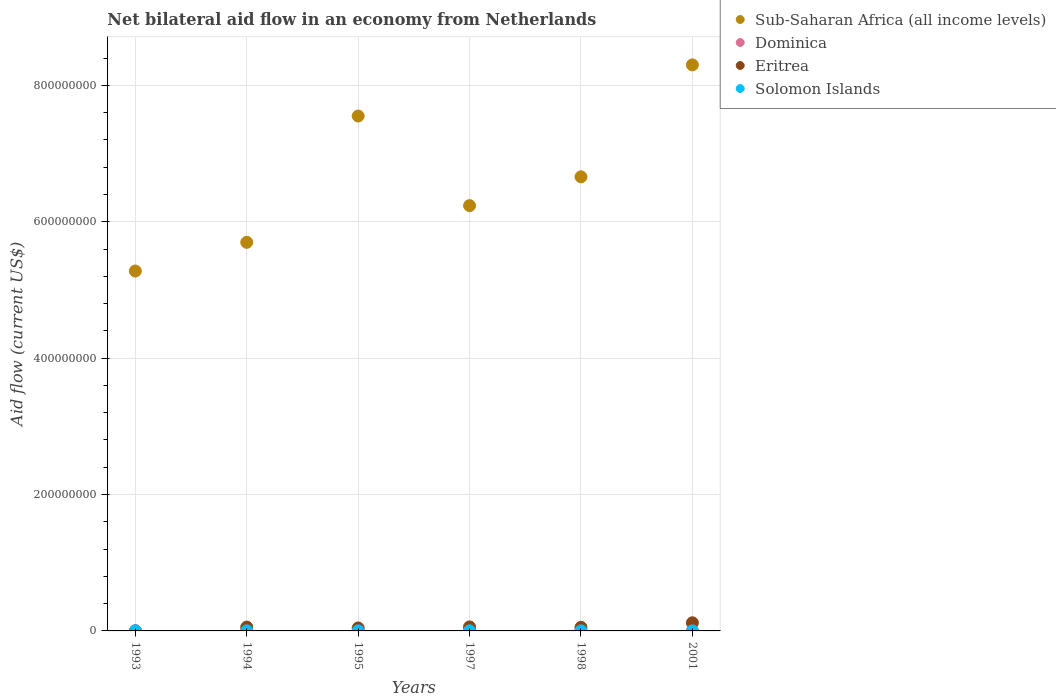How many different coloured dotlines are there?
Keep it short and to the point. 4. What is the net bilateral aid flow in Dominica in 1998?
Provide a short and direct response. 2.10e+05. Across all years, what is the minimum net bilateral aid flow in Sub-Saharan Africa (all income levels)?
Your answer should be compact. 5.28e+08. In which year was the net bilateral aid flow in Sub-Saharan Africa (all income levels) minimum?
Ensure brevity in your answer.  1993. What is the total net bilateral aid flow in Eritrea in the graph?
Give a very brief answer. 3.31e+07. What is the difference between the net bilateral aid flow in Eritrea in 1994 and that in 1998?
Your response must be concise. 2.90e+05. What is the difference between the net bilateral aid flow in Eritrea in 1993 and the net bilateral aid flow in Sub-Saharan Africa (all income levels) in 1995?
Give a very brief answer. -7.55e+08. What is the average net bilateral aid flow in Sub-Saharan Africa (all income levels) per year?
Provide a succinct answer. 6.62e+08. In the year 1994, what is the difference between the net bilateral aid flow in Solomon Islands and net bilateral aid flow in Dominica?
Offer a terse response. -4.00e+04. In how many years, is the net bilateral aid flow in Sub-Saharan Africa (all income levels) greater than 600000000 US$?
Provide a short and direct response. 4. What is the ratio of the net bilateral aid flow in Sub-Saharan Africa (all income levels) in 1994 to that in 1998?
Your answer should be compact. 0.86. What is the difference between the highest and the lowest net bilateral aid flow in Eritrea?
Provide a short and direct response. 1.19e+07. Is the sum of the net bilateral aid flow in Eritrea in 1993 and 1997 greater than the maximum net bilateral aid flow in Solomon Islands across all years?
Your response must be concise. Yes. Is it the case that in every year, the sum of the net bilateral aid flow in Dominica and net bilateral aid flow in Eritrea  is greater than the sum of net bilateral aid flow in Sub-Saharan Africa (all income levels) and net bilateral aid flow in Solomon Islands?
Provide a short and direct response. No. Is it the case that in every year, the sum of the net bilateral aid flow in Sub-Saharan Africa (all income levels) and net bilateral aid flow in Eritrea  is greater than the net bilateral aid flow in Solomon Islands?
Your response must be concise. Yes. Does the net bilateral aid flow in Dominica monotonically increase over the years?
Your answer should be very brief. No. Is the net bilateral aid flow in Dominica strictly greater than the net bilateral aid flow in Eritrea over the years?
Ensure brevity in your answer.  No. Is the net bilateral aid flow in Sub-Saharan Africa (all income levels) strictly less than the net bilateral aid flow in Dominica over the years?
Your answer should be compact. No. Are the values on the major ticks of Y-axis written in scientific E-notation?
Your answer should be compact. No. Does the graph contain any zero values?
Offer a very short reply. No. How many legend labels are there?
Your answer should be very brief. 4. What is the title of the graph?
Provide a succinct answer. Net bilateral aid flow in an economy from Netherlands. What is the label or title of the X-axis?
Offer a very short reply. Years. What is the Aid flow (current US$) in Sub-Saharan Africa (all income levels) in 1993?
Provide a short and direct response. 5.28e+08. What is the Aid flow (current US$) of Dominica in 1993?
Make the answer very short. 1.40e+05. What is the Aid flow (current US$) in Sub-Saharan Africa (all income levels) in 1994?
Provide a succinct answer. 5.70e+08. What is the Aid flow (current US$) in Eritrea in 1994?
Your answer should be very brief. 5.60e+06. What is the Aid flow (current US$) in Solomon Islands in 1994?
Your answer should be very brief. 1.30e+05. What is the Aid flow (current US$) of Sub-Saharan Africa (all income levels) in 1995?
Ensure brevity in your answer.  7.55e+08. What is the Aid flow (current US$) of Eritrea in 1995?
Offer a very short reply. 4.35e+06. What is the Aid flow (current US$) of Sub-Saharan Africa (all income levels) in 1997?
Give a very brief answer. 6.24e+08. What is the Aid flow (current US$) of Eritrea in 1997?
Offer a terse response. 5.87e+06. What is the Aid flow (current US$) in Solomon Islands in 1997?
Keep it short and to the point. 2.00e+05. What is the Aid flow (current US$) of Sub-Saharan Africa (all income levels) in 1998?
Your answer should be compact. 6.66e+08. What is the Aid flow (current US$) in Eritrea in 1998?
Offer a terse response. 5.31e+06. What is the Aid flow (current US$) of Sub-Saharan Africa (all income levels) in 2001?
Your response must be concise. 8.30e+08. What is the Aid flow (current US$) in Dominica in 2001?
Offer a terse response. 10000. What is the Aid flow (current US$) of Eritrea in 2001?
Your answer should be compact. 1.19e+07. Across all years, what is the maximum Aid flow (current US$) of Sub-Saharan Africa (all income levels)?
Provide a short and direct response. 8.30e+08. Across all years, what is the maximum Aid flow (current US$) of Dominica?
Ensure brevity in your answer.  2.30e+05. Across all years, what is the maximum Aid flow (current US$) of Eritrea?
Make the answer very short. 1.19e+07. Across all years, what is the minimum Aid flow (current US$) in Sub-Saharan Africa (all income levels)?
Offer a terse response. 5.28e+08. Across all years, what is the minimum Aid flow (current US$) of Dominica?
Your response must be concise. 10000. Across all years, what is the minimum Aid flow (current US$) in Eritrea?
Give a very brief answer. 3.00e+04. Across all years, what is the minimum Aid flow (current US$) in Solomon Islands?
Offer a terse response. 7.00e+04. What is the total Aid flow (current US$) of Sub-Saharan Africa (all income levels) in the graph?
Provide a succinct answer. 3.97e+09. What is the total Aid flow (current US$) of Dominica in the graph?
Make the answer very short. 9.10e+05. What is the total Aid flow (current US$) of Eritrea in the graph?
Offer a terse response. 3.31e+07. What is the total Aid flow (current US$) in Solomon Islands in the graph?
Your answer should be compact. 8.50e+05. What is the difference between the Aid flow (current US$) in Sub-Saharan Africa (all income levels) in 1993 and that in 1994?
Keep it short and to the point. -4.21e+07. What is the difference between the Aid flow (current US$) of Eritrea in 1993 and that in 1994?
Provide a short and direct response. -5.57e+06. What is the difference between the Aid flow (current US$) in Sub-Saharan Africa (all income levels) in 1993 and that in 1995?
Provide a succinct answer. -2.27e+08. What is the difference between the Aid flow (current US$) in Dominica in 1993 and that in 1995?
Give a very brief answer. -9.00e+04. What is the difference between the Aid flow (current US$) in Eritrea in 1993 and that in 1995?
Provide a succinct answer. -4.32e+06. What is the difference between the Aid flow (current US$) in Solomon Islands in 1993 and that in 1995?
Your response must be concise. 4.00e+04. What is the difference between the Aid flow (current US$) of Sub-Saharan Africa (all income levels) in 1993 and that in 1997?
Make the answer very short. -9.59e+07. What is the difference between the Aid flow (current US$) of Eritrea in 1993 and that in 1997?
Ensure brevity in your answer.  -5.84e+06. What is the difference between the Aid flow (current US$) in Sub-Saharan Africa (all income levels) in 1993 and that in 1998?
Your response must be concise. -1.38e+08. What is the difference between the Aid flow (current US$) of Eritrea in 1993 and that in 1998?
Provide a short and direct response. -5.28e+06. What is the difference between the Aid flow (current US$) in Solomon Islands in 1993 and that in 1998?
Offer a very short reply. 5.00e+04. What is the difference between the Aid flow (current US$) in Sub-Saharan Africa (all income levels) in 1993 and that in 2001?
Provide a short and direct response. -3.02e+08. What is the difference between the Aid flow (current US$) of Dominica in 1993 and that in 2001?
Ensure brevity in your answer.  1.30e+05. What is the difference between the Aid flow (current US$) in Eritrea in 1993 and that in 2001?
Provide a succinct answer. -1.19e+07. What is the difference between the Aid flow (current US$) in Solomon Islands in 1993 and that in 2001?
Give a very brief answer. 1.10e+05. What is the difference between the Aid flow (current US$) in Sub-Saharan Africa (all income levels) in 1994 and that in 1995?
Offer a terse response. -1.85e+08. What is the difference between the Aid flow (current US$) in Eritrea in 1994 and that in 1995?
Make the answer very short. 1.25e+06. What is the difference between the Aid flow (current US$) in Sub-Saharan Africa (all income levels) in 1994 and that in 1997?
Your answer should be very brief. -5.38e+07. What is the difference between the Aid flow (current US$) of Sub-Saharan Africa (all income levels) in 1994 and that in 1998?
Your answer should be compact. -9.60e+07. What is the difference between the Aid flow (current US$) of Eritrea in 1994 and that in 1998?
Offer a terse response. 2.90e+05. What is the difference between the Aid flow (current US$) in Sub-Saharan Africa (all income levels) in 1994 and that in 2001?
Your response must be concise. -2.60e+08. What is the difference between the Aid flow (current US$) of Dominica in 1994 and that in 2001?
Offer a very short reply. 1.60e+05. What is the difference between the Aid flow (current US$) of Eritrea in 1994 and that in 2001?
Keep it short and to the point. -6.32e+06. What is the difference between the Aid flow (current US$) of Solomon Islands in 1994 and that in 2001?
Your response must be concise. 6.00e+04. What is the difference between the Aid flow (current US$) of Sub-Saharan Africa (all income levels) in 1995 and that in 1997?
Ensure brevity in your answer.  1.31e+08. What is the difference between the Aid flow (current US$) of Eritrea in 1995 and that in 1997?
Your response must be concise. -1.52e+06. What is the difference between the Aid flow (current US$) of Sub-Saharan Africa (all income levels) in 1995 and that in 1998?
Make the answer very short. 8.91e+07. What is the difference between the Aid flow (current US$) in Eritrea in 1995 and that in 1998?
Offer a terse response. -9.60e+05. What is the difference between the Aid flow (current US$) in Solomon Islands in 1995 and that in 1998?
Provide a succinct answer. 10000. What is the difference between the Aid flow (current US$) in Sub-Saharan Africa (all income levels) in 1995 and that in 2001?
Offer a terse response. -7.50e+07. What is the difference between the Aid flow (current US$) in Dominica in 1995 and that in 2001?
Your response must be concise. 2.20e+05. What is the difference between the Aid flow (current US$) in Eritrea in 1995 and that in 2001?
Offer a very short reply. -7.57e+06. What is the difference between the Aid flow (current US$) of Sub-Saharan Africa (all income levels) in 1997 and that in 1998?
Offer a very short reply. -4.22e+07. What is the difference between the Aid flow (current US$) of Eritrea in 1997 and that in 1998?
Your answer should be very brief. 5.60e+05. What is the difference between the Aid flow (current US$) of Sub-Saharan Africa (all income levels) in 1997 and that in 2001?
Provide a short and direct response. -2.06e+08. What is the difference between the Aid flow (current US$) in Eritrea in 1997 and that in 2001?
Offer a terse response. -6.05e+06. What is the difference between the Aid flow (current US$) of Solomon Islands in 1997 and that in 2001?
Give a very brief answer. 1.30e+05. What is the difference between the Aid flow (current US$) in Sub-Saharan Africa (all income levels) in 1998 and that in 2001?
Ensure brevity in your answer.  -1.64e+08. What is the difference between the Aid flow (current US$) of Eritrea in 1998 and that in 2001?
Your answer should be compact. -6.61e+06. What is the difference between the Aid flow (current US$) of Solomon Islands in 1998 and that in 2001?
Keep it short and to the point. 6.00e+04. What is the difference between the Aid flow (current US$) in Sub-Saharan Africa (all income levels) in 1993 and the Aid flow (current US$) in Dominica in 1994?
Your answer should be compact. 5.28e+08. What is the difference between the Aid flow (current US$) of Sub-Saharan Africa (all income levels) in 1993 and the Aid flow (current US$) of Eritrea in 1994?
Offer a very short reply. 5.22e+08. What is the difference between the Aid flow (current US$) in Sub-Saharan Africa (all income levels) in 1993 and the Aid flow (current US$) in Solomon Islands in 1994?
Offer a terse response. 5.28e+08. What is the difference between the Aid flow (current US$) in Dominica in 1993 and the Aid flow (current US$) in Eritrea in 1994?
Your answer should be compact. -5.46e+06. What is the difference between the Aid flow (current US$) in Dominica in 1993 and the Aid flow (current US$) in Solomon Islands in 1994?
Keep it short and to the point. 10000. What is the difference between the Aid flow (current US$) of Sub-Saharan Africa (all income levels) in 1993 and the Aid flow (current US$) of Dominica in 1995?
Your response must be concise. 5.27e+08. What is the difference between the Aid flow (current US$) in Sub-Saharan Africa (all income levels) in 1993 and the Aid flow (current US$) in Eritrea in 1995?
Your answer should be compact. 5.23e+08. What is the difference between the Aid flow (current US$) of Sub-Saharan Africa (all income levels) in 1993 and the Aid flow (current US$) of Solomon Islands in 1995?
Keep it short and to the point. 5.28e+08. What is the difference between the Aid flow (current US$) of Dominica in 1993 and the Aid flow (current US$) of Eritrea in 1995?
Your answer should be very brief. -4.21e+06. What is the difference between the Aid flow (current US$) of Dominica in 1993 and the Aid flow (current US$) of Solomon Islands in 1995?
Make the answer very short. 0. What is the difference between the Aid flow (current US$) of Sub-Saharan Africa (all income levels) in 1993 and the Aid flow (current US$) of Dominica in 1997?
Offer a terse response. 5.28e+08. What is the difference between the Aid flow (current US$) of Sub-Saharan Africa (all income levels) in 1993 and the Aid flow (current US$) of Eritrea in 1997?
Provide a short and direct response. 5.22e+08. What is the difference between the Aid flow (current US$) of Sub-Saharan Africa (all income levels) in 1993 and the Aid flow (current US$) of Solomon Islands in 1997?
Your response must be concise. 5.27e+08. What is the difference between the Aid flow (current US$) in Dominica in 1993 and the Aid flow (current US$) in Eritrea in 1997?
Provide a short and direct response. -5.73e+06. What is the difference between the Aid flow (current US$) of Dominica in 1993 and the Aid flow (current US$) of Solomon Islands in 1997?
Keep it short and to the point. -6.00e+04. What is the difference between the Aid flow (current US$) in Eritrea in 1993 and the Aid flow (current US$) in Solomon Islands in 1997?
Make the answer very short. -1.70e+05. What is the difference between the Aid flow (current US$) of Sub-Saharan Africa (all income levels) in 1993 and the Aid flow (current US$) of Dominica in 1998?
Your answer should be compact. 5.27e+08. What is the difference between the Aid flow (current US$) in Sub-Saharan Africa (all income levels) in 1993 and the Aid flow (current US$) in Eritrea in 1998?
Ensure brevity in your answer.  5.22e+08. What is the difference between the Aid flow (current US$) of Sub-Saharan Africa (all income levels) in 1993 and the Aid flow (current US$) of Solomon Islands in 1998?
Offer a very short reply. 5.28e+08. What is the difference between the Aid flow (current US$) in Dominica in 1993 and the Aid flow (current US$) in Eritrea in 1998?
Your answer should be very brief. -5.17e+06. What is the difference between the Aid flow (current US$) in Dominica in 1993 and the Aid flow (current US$) in Solomon Islands in 1998?
Provide a short and direct response. 10000. What is the difference between the Aid flow (current US$) in Eritrea in 1993 and the Aid flow (current US$) in Solomon Islands in 1998?
Provide a succinct answer. -1.00e+05. What is the difference between the Aid flow (current US$) of Sub-Saharan Africa (all income levels) in 1993 and the Aid flow (current US$) of Dominica in 2001?
Make the answer very short. 5.28e+08. What is the difference between the Aid flow (current US$) of Sub-Saharan Africa (all income levels) in 1993 and the Aid flow (current US$) of Eritrea in 2001?
Offer a terse response. 5.16e+08. What is the difference between the Aid flow (current US$) of Sub-Saharan Africa (all income levels) in 1993 and the Aid flow (current US$) of Solomon Islands in 2001?
Keep it short and to the point. 5.28e+08. What is the difference between the Aid flow (current US$) of Dominica in 1993 and the Aid flow (current US$) of Eritrea in 2001?
Your answer should be very brief. -1.18e+07. What is the difference between the Aid flow (current US$) in Sub-Saharan Africa (all income levels) in 1994 and the Aid flow (current US$) in Dominica in 1995?
Keep it short and to the point. 5.70e+08. What is the difference between the Aid flow (current US$) of Sub-Saharan Africa (all income levels) in 1994 and the Aid flow (current US$) of Eritrea in 1995?
Your answer should be compact. 5.65e+08. What is the difference between the Aid flow (current US$) in Sub-Saharan Africa (all income levels) in 1994 and the Aid flow (current US$) in Solomon Islands in 1995?
Give a very brief answer. 5.70e+08. What is the difference between the Aid flow (current US$) of Dominica in 1994 and the Aid flow (current US$) of Eritrea in 1995?
Keep it short and to the point. -4.18e+06. What is the difference between the Aid flow (current US$) of Eritrea in 1994 and the Aid flow (current US$) of Solomon Islands in 1995?
Ensure brevity in your answer.  5.46e+06. What is the difference between the Aid flow (current US$) of Sub-Saharan Africa (all income levels) in 1994 and the Aid flow (current US$) of Dominica in 1997?
Provide a short and direct response. 5.70e+08. What is the difference between the Aid flow (current US$) in Sub-Saharan Africa (all income levels) in 1994 and the Aid flow (current US$) in Eritrea in 1997?
Keep it short and to the point. 5.64e+08. What is the difference between the Aid flow (current US$) in Sub-Saharan Africa (all income levels) in 1994 and the Aid flow (current US$) in Solomon Islands in 1997?
Your response must be concise. 5.70e+08. What is the difference between the Aid flow (current US$) in Dominica in 1994 and the Aid flow (current US$) in Eritrea in 1997?
Offer a very short reply. -5.70e+06. What is the difference between the Aid flow (current US$) in Eritrea in 1994 and the Aid flow (current US$) in Solomon Islands in 1997?
Keep it short and to the point. 5.40e+06. What is the difference between the Aid flow (current US$) of Sub-Saharan Africa (all income levels) in 1994 and the Aid flow (current US$) of Dominica in 1998?
Your answer should be very brief. 5.70e+08. What is the difference between the Aid flow (current US$) of Sub-Saharan Africa (all income levels) in 1994 and the Aid flow (current US$) of Eritrea in 1998?
Keep it short and to the point. 5.64e+08. What is the difference between the Aid flow (current US$) in Sub-Saharan Africa (all income levels) in 1994 and the Aid flow (current US$) in Solomon Islands in 1998?
Your answer should be compact. 5.70e+08. What is the difference between the Aid flow (current US$) of Dominica in 1994 and the Aid flow (current US$) of Eritrea in 1998?
Provide a short and direct response. -5.14e+06. What is the difference between the Aid flow (current US$) in Dominica in 1994 and the Aid flow (current US$) in Solomon Islands in 1998?
Provide a succinct answer. 4.00e+04. What is the difference between the Aid flow (current US$) of Eritrea in 1994 and the Aid flow (current US$) of Solomon Islands in 1998?
Make the answer very short. 5.47e+06. What is the difference between the Aid flow (current US$) in Sub-Saharan Africa (all income levels) in 1994 and the Aid flow (current US$) in Dominica in 2001?
Provide a short and direct response. 5.70e+08. What is the difference between the Aid flow (current US$) of Sub-Saharan Africa (all income levels) in 1994 and the Aid flow (current US$) of Eritrea in 2001?
Make the answer very short. 5.58e+08. What is the difference between the Aid flow (current US$) of Sub-Saharan Africa (all income levels) in 1994 and the Aid flow (current US$) of Solomon Islands in 2001?
Make the answer very short. 5.70e+08. What is the difference between the Aid flow (current US$) of Dominica in 1994 and the Aid flow (current US$) of Eritrea in 2001?
Your answer should be very brief. -1.18e+07. What is the difference between the Aid flow (current US$) of Eritrea in 1994 and the Aid flow (current US$) of Solomon Islands in 2001?
Make the answer very short. 5.53e+06. What is the difference between the Aid flow (current US$) in Sub-Saharan Africa (all income levels) in 1995 and the Aid flow (current US$) in Dominica in 1997?
Ensure brevity in your answer.  7.55e+08. What is the difference between the Aid flow (current US$) in Sub-Saharan Africa (all income levels) in 1995 and the Aid flow (current US$) in Eritrea in 1997?
Give a very brief answer. 7.49e+08. What is the difference between the Aid flow (current US$) in Sub-Saharan Africa (all income levels) in 1995 and the Aid flow (current US$) in Solomon Islands in 1997?
Provide a succinct answer. 7.55e+08. What is the difference between the Aid flow (current US$) in Dominica in 1995 and the Aid flow (current US$) in Eritrea in 1997?
Offer a very short reply. -5.64e+06. What is the difference between the Aid flow (current US$) of Dominica in 1995 and the Aid flow (current US$) of Solomon Islands in 1997?
Offer a terse response. 3.00e+04. What is the difference between the Aid flow (current US$) of Eritrea in 1995 and the Aid flow (current US$) of Solomon Islands in 1997?
Offer a very short reply. 4.15e+06. What is the difference between the Aid flow (current US$) of Sub-Saharan Africa (all income levels) in 1995 and the Aid flow (current US$) of Dominica in 1998?
Provide a succinct answer. 7.55e+08. What is the difference between the Aid flow (current US$) in Sub-Saharan Africa (all income levels) in 1995 and the Aid flow (current US$) in Eritrea in 1998?
Make the answer very short. 7.50e+08. What is the difference between the Aid flow (current US$) in Sub-Saharan Africa (all income levels) in 1995 and the Aid flow (current US$) in Solomon Islands in 1998?
Provide a short and direct response. 7.55e+08. What is the difference between the Aid flow (current US$) of Dominica in 1995 and the Aid flow (current US$) of Eritrea in 1998?
Provide a succinct answer. -5.08e+06. What is the difference between the Aid flow (current US$) of Dominica in 1995 and the Aid flow (current US$) of Solomon Islands in 1998?
Make the answer very short. 1.00e+05. What is the difference between the Aid flow (current US$) in Eritrea in 1995 and the Aid flow (current US$) in Solomon Islands in 1998?
Your answer should be very brief. 4.22e+06. What is the difference between the Aid flow (current US$) of Sub-Saharan Africa (all income levels) in 1995 and the Aid flow (current US$) of Dominica in 2001?
Keep it short and to the point. 7.55e+08. What is the difference between the Aid flow (current US$) of Sub-Saharan Africa (all income levels) in 1995 and the Aid flow (current US$) of Eritrea in 2001?
Provide a short and direct response. 7.43e+08. What is the difference between the Aid flow (current US$) in Sub-Saharan Africa (all income levels) in 1995 and the Aid flow (current US$) in Solomon Islands in 2001?
Offer a very short reply. 7.55e+08. What is the difference between the Aid flow (current US$) of Dominica in 1995 and the Aid flow (current US$) of Eritrea in 2001?
Provide a short and direct response. -1.17e+07. What is the difference between the Aid flow (current US$) in Dominica in 1995 and the Aid flow (current US$) in Solomon Islands in 2001?
Ensure brevity in your answer.  1.60e+05. What is the difference between the Aid flow (current US$) in Eritrea in 1995 and the Aid flow (current US$) in Solomon Islands in 2001?
Keep it short and to the point. 4.28e+06. What is the difference between the Aid flow (current US$) of Sub-Saharan Africa (all income levels) in 1997 and the Aid flow (current US$) of Dominica in 1998?
Provide a short and direct response. 6.23e+08. What is the difference between the Aid flow (current US$) of Sub-Saharan Africa (all income levels) in 1997 and the Aid flow (current US$) of Eritrea in 1998?
Provide a short and direct response. 6.18e+08. What is the difference between the Aid flow (current US$) in Sub-Saharan Africa (all income levels) in 1997 and the Aid flow (current US$) in Solomon Islands in 1998?
Provide a short and direct response. 6.23e+08. What is the difference between the Aid flow (current US$) of Dominica in 1997 and the Aid flow (current US$) of Eritrea in 1998?
Offer a very short reply. -5.16e+06. What is the difference between the Aid flow (current US$) in Eritrea in 1997 and the Aid flow (current US$) in Solomon Islands in 1998?
Your response must be concise. 5.74e+06. What is the difference between the Aid flow (current US$) in Sub-Saharan Africa (all income levels) in 1997 and the Aid flow (current US$) in Dominica in 2001?
Ensure brevity in your answer.  6.24e+08. What is the difference between the Aid flow (current US$) of Sub-Saharan Africa (all income levels) in 1997 and the Aid flow (current US$) of Eritrea in 2001?
Your answer should be compact. 6.12e+08. What is the difference between the Aid flow (current US$) of Sub-Saharan Africa (all income levels) in 1997 and the Aid flow (current US$) of Solomon Islands in 2001?
Provide a succinct answer. 6.24e+08. What is the difference between the Aid flow (current US$) in Dominica in 1997 and the Aid flow (current US$) in Eritrea in 2001?
Provide a short and direct response. -1.18e+07. What is the difference between the Aid flow (current US$) in Eritrea in 1997 and the Aid flow (current US$) in Solomon Islands in 2001?
Your answer should be very brief. 5.80e+06. What is the difference between the Aid flow (current US$) of Sub-Saharan Africa (all income levels) in 1998 and the Aid flow (current US$) of Dominica in 2001?
Offer a very short reply. 6.66e+08. What is the difference between the Aid flow (current US$) in Sub-Saharan Africa (all income levels) in 1998 and the Aid flow (current US$) in Eritrea in 2001?
Offer a terse response. 6.54e+08. What is the difference between the Aid flow (current US$) of Sub-Saharan Africa (all income levels) in 1998 and the Aid flow (current US$) of Solomon Islands in 2001?
Give a very brief answer. 6.66e+08. What is the difference between the Aid flow (current US$) in Dominica in 1998 and the Aid flow (current US$) in Eritrea in 2001?
Offer a terse response. -1.17e+07. What is the difference between the Aid flow (current US$) of Eritrea in 1998 and the Aid flow (current US$) of Solomon Islands in 2001?
Offer a terse response. 5.24e+06. What is the average Aid flow (current US$) of Sub-Saharan Africa (all income levels) per year?
Offer a terse response. 6.62e+08. What is the average Aid flow (current US$) in Dominica per year?
Your answer should be compact. 1.52e+05. What is the average Aid flow (current US$) in Eritrea per year?
Your answer should be very brief. 5.51e+06. What is the average Aid flow (current US$) of Solomon Islands per year?
Keep it short and to the point. 1.42e+05. In the year 1993, what is the difference between the Aid flow (current US$) in Sub-Saharan Africa (all income levels) and Aid flow (current US$) in Dominica?
Provide a succinct answer. 5.28e+08. In the year 1993, what is the difference between the Aid flow (current US$) in Sub-Saharan Africa (all income levels) and Aid flow (current US$) in Eritrea?
Your response must be concise. 5.28e+08. In the year 1993, what is the difference between the Aid flow (current US$) of Sub-Saharan Africa (all income levels) and Aid flow (current US$) of Solomon Islands?
Keep it short and to the point. 5.28e+08. In the year 1993, what is the difference between the Aid flow (current US$) in Eritrea and Aid flow (current US$) in Solomon Islands?
Provide a short and direct response. -1.50e+05. In the year 1994, what is the difference between the Aid flow (current US$) in Sub-Saharan Africa (all income levels) and Aid flow (current US$) in Dominica?
Offer a terse response. 5.70e+08. In the year 1994, what is the difference between the Aid flow (current US$) in Sub-Saharan Africa (all income levels) and Aid flow (current US$) in Eritrea?
Make the answer very short. 5.64e+08. In the year 1994, what is the difference between the Aid flow (current US$) in Sub-Saharan Africa (all income levels) and Aid flow (current US$) in Solomon Islands?
Your answer should be very brief. 5.70e+08. In the year 1994, what is the difference between the Aid flow (current US$) of Dominica and Aid flow (current US$) of Eritrea?
Ensure brevity in your answer.  -5.43e+06. In the year 1994, what is the difference between the Aid flow (current US$) of Dominica and Aid flow (current US$) of Solomon Islands?
Your answer should be very brief. 4.00e+04. In the year 1994, what is the difference between the Aid flow (current US$) in Eritrea and Aid flow (current US$) in Solomon Islands?
Give a very brief answer. 5.47e+06. In the year 1995, what is the difference between the Aid flow (current US$) in Sub-Saharan Africa (all income levels) and Aid flow (current US$) in Dominica?
Your answer should be very brief. 7.55e+08. In the year 1995, what is the difference between the Aid flow (current US$) in Sub-Saharan Africa (all income levels) and Aid flow (current US$) in Eritrea?
Offer a very short reply. 7.51e+08. In the year 1995, what is the difference between the Aid flow (current US$) in Sub-Saharan Africa (all income levels) and Aid flow (current US$) in Solomon Islands?
Keep it short and to the point. 7.55e+08. In the year 1995, what is the difference between the Aid flow (current US$) of Dominica and Aid flow (current US$) of Eritrea?
Your response must be concise. -4.12e+06. In the year 1995, what is the difference between the Aid flow (current US$) of Eritrea and Aid flow (current US$) of Solomon Islands?
Make the answer very short. 4.21e+06. In the year 1997, what is the difference between the Aid flow (current US$) of Sub-Saharan Africa (all income levels) and Aid flow (current US$) of Dominica?
Your answer should be compact. 6.23e+08. In the year 1997, what is the difference between the Aid flow (current US$) in Sub-Saharan Africa (all income levels) and Aid flow (current US$) in Eritrea?
Offer a terse response. 6.18e+08. In the year 1997, what is the difference between the Aid flow (current US$) of Sub-Saharan Africa (all income levels) and Aid flow (current US$) of Solomon Islands?
Your response must be concise. 6.23e+08. In the year 1997, what is the difference between the Aid flow (current US$) of Dominica and Aid flow (current US$) of Eritrea?
Give a very brief answer. -5.72e+06. In the year 1997, what is the difference between the Aid flow (current US$) of Eritrea and Aid flow (current US$) of Solomon Islands?
Your answer should be very brief. 5.67e+06. In the year 1998, what is the difference between the Aid flow (current US$) in Sub-Saharan Africa (all income levels) and Aid flow (current US$) in Dominica?
Make the answer very short. 6.66e+08. In the year 1998, what is the difference between the Aid flow (current US$) of Sub-Saharan Africa (all income levels) and Aid flow (current US$) of Eritrea?
Provide a succinct answer. 6.61e+08. In the year 1998, what is the difference between the Aid flow (current US$) in Sub-Saharan Africa (all income levels) and Aid flow (current US$) in Solomon Islands?
Provide a succinct answer. 6.66e+08. In the year 1998, what is the difference between the Aid flow (current US$) of Dominica and Aid flow (current US$) of Eritrea?
Keep it short and to the point. -5.10e+06. In the year 1998, what is the difference between the Aid flow (current US$) of Dominica and Aid flow (current US$) of Solomon Islands?
Your response must be concise. 8.00e+04. In the year 1998, what is the difference between the Aid flow (current US$) in Eritrea and Aid flow (current US$) in Solomon Islands?
Keep it short and to the point. 5.18e+06. In the year 2001, what is the difference between the Aid flow (current US$) of Sub-Saharan Africa (all income levels) and Aid flow (current US$) of Dominica?
Give a very brief answer. 8.30e+08. In the year 2001, what is the difference between the Aid flow (current US$) in Sub-Saharan Africa (all income levels) and Aid flow (current US$) in Eritrea?
Your answer should be compact. 8.18e+08. In the year 2001, what is the difference between the Aid flow (current US$) of Sub-Saharan Africa (all income levels) and Aid flow (current US$) of Solomon Islands?
Your answer should be very brief. 8.30e+08. In the year 2001, what is the difference between the Aid flow (current US$) of Dominica and Aid flow (current US$) of Eritrea?
Your answer should be compact. -1.19e+07. In the year 2001, what is the difference between the Aid flow (current US$) of Dominica and Aid flow (current US$) of Solomon Islands?
Give a very brief answer. -6.00e+04. In the year 2001, what is the difference between the Aid flow (current US$) in Eritrea and Aid flow (current US$) in Solomon Islands?
Offer a very short reply. 1.18e+07. What is the ratio of the Aid flow (current US$) in Sub-Saharan Africa (all income levels) in 1993 to that in 1994?
Your answer should be compact. 0.93. What is the ratio of the Aid flow (current US$) of Dominica in 1993 to that in 1994?
Your answer should be very brief. 0.82. What is the ratio of the Aid flow (current US$) in Eritrea in 1993 to that in 1994?
Your answer should be very brief. 0.01. What is the ratio of the Aid flow (current US$) in Solomon Islands in 1993 to that in 1994?
Ensure brevity in your answer.  1.38. What is the ratio of the Aid flow (current US$) in Sub-Saharan Africa (all income levels) in 1993 to that in 1995?
Your answer should be very brief. 0.7. What is the ratio of the Aid flow (current US$) of Dominica in 1993 to that in 1995?
Provide a short and direct response. 0.61. What is the ratio of the Aid flow (current US$) of Eritrea in 1993 to that in 1995?
Your answer should be very brief. 0.01. What is the ratio of the Aid flow (current US$) of Sub-Saharan Africa (all income levels) in 1993 to that in 1997?
Ensure brevity in your answer.  0.85. What is the ratio of the Aid flow (current US$) of Dominica in 1993 to that in 1997?
Provide a short and direct response. 0.93. What is the ratio of the Aid flow (current US$) in Eritrea in 1993 to that in 1997?
Offer a terse response. 0.01. What is the ratio of the Aid flow (current US$) in Solomon Islands in 1993 to that in 1997?
Offer a very short reply. 0.9. What is the ratio of the Aid flow (current US$) in Sub-Saharan Africa (all income levels) in 1993 to that in 1998?
Give a very brief answer. 0.79. What is the ratio of the Aid flow (current US$) of Eritrea in 1993 to that in 1998?
Provide a short and direct response. 0.01. What is the ratio of the Aid flow (current US$) in Solomon Islands in 1993 to that in 1998?
Offer a terse response. 1.38. What is the ratio of the Aid flow (current US$) in Sub-Saharan Africa (all income levels) in 1993 to that in 2001?
Make the answer very short. 0.64. What is the ratio of the Aid flow (current US$) of Dominica in 1993 to that in 2001?
Give a very brief answer. 14. What is the ratio of the Aid flow (current US$) of Eritrea in 1993 to that in 2001?
Your response must be concise. 0. What is the ratio of the Aid flow (current US$) of Solomon Islands in 1993 to that in 2001?
Your answer should be compact. 2.57. What is the ratio of the Aid flow (current US$) of Sub-Saharan Africa (all income levels) in 1994 to that in 1995?
Your answer should be very brief. 0.75. What is the ratio of the Aid flow (current US$) in Dominica in 1994 to that in 1995?
Provide a short and direct response. 0.74. What is the ratio of the Aid flow (current US$) in Eritrea in 1994 to that in 1995?
Provide a short and direct response. 1.29. What is the ratio of the Aid flow (current US$) in Sub-Saharan Africa (all income levels) in 1994 to that in 1997?
Ensure brevity in your answer.  0.91. What is the ratio of the Aid flow (current US$) of Dominica in 1994 to that in 1997?
Your response must be concise. 1.13. What is the ratio of the Aid flow (current US$) in Eritrea in 1994 to that in 1997?
Your response must be concise. 0.95. What is the ratio of the Aid flow (current US$) in Solomon Islands in 1994 to that in 1997?
Ensure brevity in your answer.  0.65. What is the ratio of the Aid flow (current US$) in Sub-Saharan Africa (all income levels) in 1994 to that in 1998?
Make the answer very short. 0.86. What is the ratio of the Aid flow (current US$) in Dominica in 1994 to that in 1998?
Make the answer very short. 0.81. What is the ratio of the Aid flow (current US$) in Eritrea in 1994 to that in 1998?
Make the answer very short. 1.05. What is the ratio of the Aid flow (current US$) of Sub-Saharan Africa (all income levels) in 1994 to that in 2001?
Ensure brevity in your answer.  0.69. What is the ratio of the Aid flow (current US$) in Eritrea in 1994 to that in 2001?
Ensure brevity in your answer.  0.47. What is the ratio of the Aid flow (current US$) of Solomon Islands in 1994 to that in 2001?
Your answer should be very brief. 1.86. What is the ratio of the Aid flow (current US$) of Sub-Saharan Africa (all income levels) in 1995 to that in 1997?
Ensure brevity in your answer.  1.21. What is the ratio of the Aid flow (current US$) in Dominica in 1995 to that in 1997?
Offer a very short reply. 1.53. What is the ratio of the Aid flow (current US$) in Eritrea in 1995 to that in 1997?
Ensure brevity in your answer.  0.74. What is the ratio of the Aid flow (current US$) in Sub-Saharan Africa (all income levels) in 1995 to that in 1998?
Your response must be concise. 1.13. What is the ratio of the Aid flow (current US$) in Dominica in 1995 to that in 1998?
Offer a terse response. 1.1. What is the ratio of the Aid flow (current US$) in Eritrea in 1995 to that in 1998?
Provide a short and direct response. 0.82. What is the ratio of the Aid flow (current US$) of Sub-Saharan Africa (all income levels) in 1995 to that in 2001?
Make the answer very short. 0.91. What is the ratio of the Aid flow (current US$) of Eritrea in 1995 to that in 2001?
Your response must be concise. 0.36. What is the ratio of the Aid flow (current US$) of Sub-Saharan Africa (all income levels) in 1997 to that in 1998?
Give a very brief answer. 0.94. What is the ratio of the Aid flow (current US$) of Dominica in 1997 to that in 1998?
Offer a terse response. 0.71. What is the ratio of the Aid flow (current US$) in Eritrea in 1997 to that in 1998?
Offer a terse response. 1.11. What is the ratio of the Aid flow (current US$) of Solomon Islands in 1997 to that in 1998?
Your answer should be compact. 1.54. What is the ratio of the Aid flow (current US$) in Sub-Saharan Africa (all income levels) in 1997 to that in 2001?
Offer a terse response. 0.75. What is the ratio of the Aid flow (current US$) of Dominica in 1997 to that in 2001?
Your response must be concise. 15. What is the ratio of the Aid flow (current US$) in Eritrea in 1997 to that in 2001?
Your answer should be very brief. 0.49. What is the ratio of the Aid flow (current US$) of Solomon Islands in 1997 to that in 2001?
Keep it short and to the point. 2.86. What is the ratio of the Aid flow (current US$) in Sub-Saharan Africa (all income levels) in 1998 to that in 2001?
Give a very brief answer. 0.8. What is the ratio of the Aid flow (current US$) in Dominica in 1998 to that in 2001?
Give a very brief answer. 21. What is the ratio of the Aid flow (current US$) in Eritrea in 1998 to that in 2001?
Offer a very short reply. 0.45. What is the ratio of the Aid flow (current US$) in Solomon Islands in 1998 to that in 2001?
Offer a very short reply. 1.86. What is the difference between the highest and the second highest Aid flow (current US$) of Sub-Saharan Africa (all income levels)?
Provide a succinct answer. 7.50e+07. What is the difference between the highest and the second highest Aid flow (current US$) in Dominica?
Your response must be concise. 2.00e+04. What is the difference between the highest and the second highest Aid flow (current US$) of Eritrea?
Provide a succinct answer. 6.05e+06. What is the difference between the highest and the second highest Aid flow (current US$) in Solomon Islands?
Make the answer very short. 2.00e+04. What is the difference between the highest and the lowest Aid flow (current US$) of Sub-Saharan Africa (all income levels)?
Offer a very short reply. 3.02e+08. What is the difference between the highest and the lowest Aid flow (current US$) of Eritrea?
Offer a very short reply. 1.19e+07. 